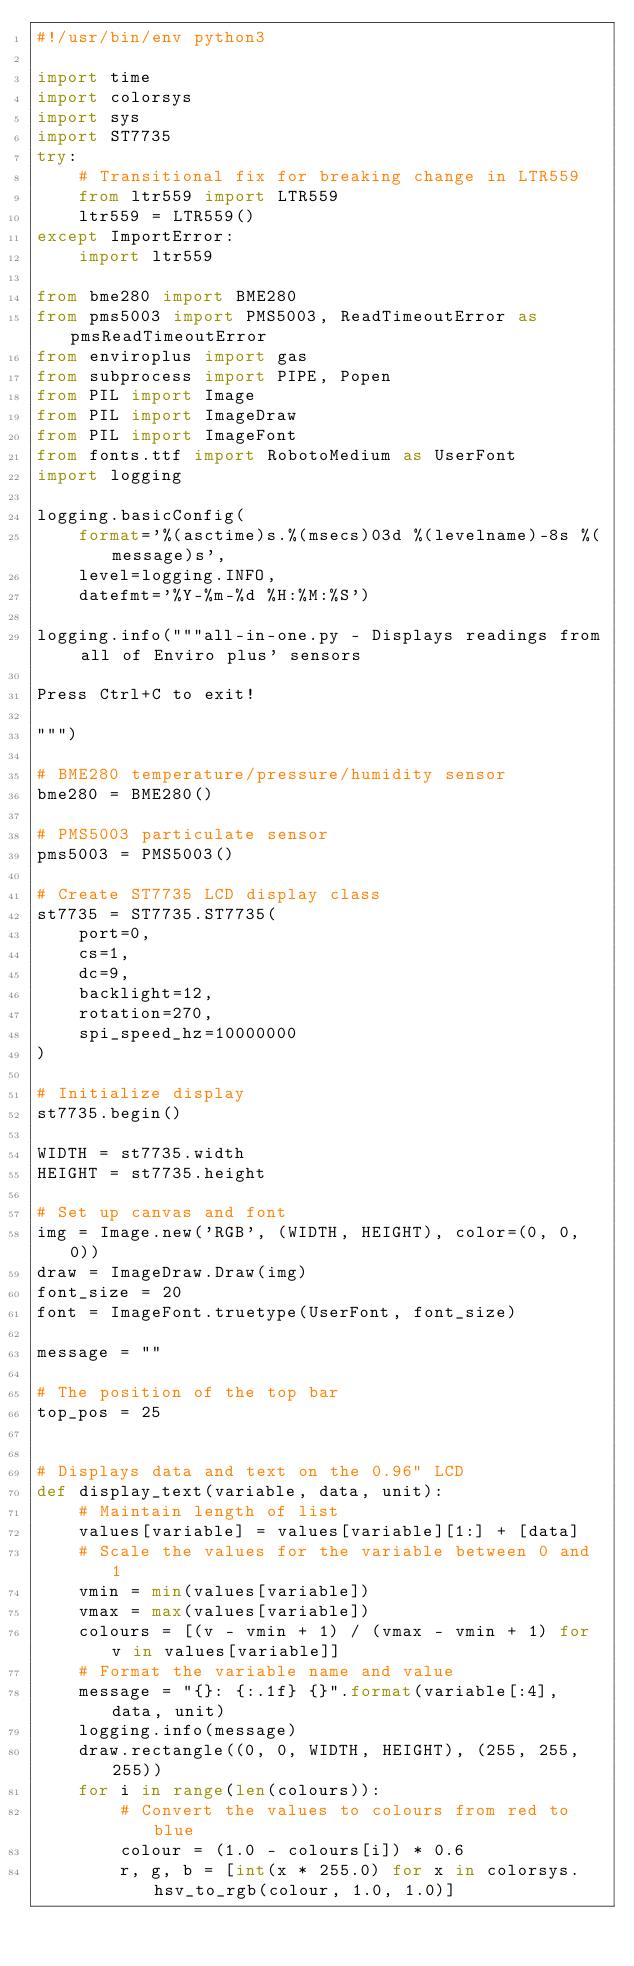<code> <loc_0><loc_0><loc_500><loc_500><_Python_>#!/usr/bin/env python3

import time
import colorsys
import sys
import ST7735
try:
    # Transitional fix for breaking change in LTR559
    from ltr559 import LTR559
    ltr559 = LTR559()
except ImportError:
    import ltr559

from bme280 import BME280
from pms5003 import PMS5003, ReadTimeoutError as pmsReadTimeoutError
from enviroplus import gas
from subprocess import PIPE, Popen
from PIL import Image
from PIL import ImageDraw
from PIL import ImageFont
from fonts.ttf import RobotoMedium as UserFont
import logging

logging.basicConfig(
    format='%(asctime)s.%(msecs)03d %(levelname)-8s %(message)s',
    level=logging.INFO,
    datefmt='%Y-%m-%d %H:%M:%S')

logging.info("""all-in-one.py - Displays readings from all of Enviro plus' sensors

Press Ctrl+C to exit!

""")

# BME280 temperature/pressure/humidity sensor
bme280 = BME280()

# PMS5003 particulate sensor
pms5003 = PMS5003()

# Create ST7735 LCD display class
st7735 = ST7735.ST7735(
    port=0,
    cs=1,
    dc=9,
    backlight=12,
    rotation=270,
    spi_speed_hz=10000000
)

# Initialize display
st7735.begin()

WIDTH = st7735.width
HEIGHT = st7735.height

# Set up canvas and font
img = Image.new('RGB', (WIDTH, HEIGHT), color=(0, 0, 0))
draw = ImageDraw.Draw(img)
font_size = 20
font = ImageFont.truetype(UserFont, font_size)

message = ""

# The position of the top bar
top_pos = 25


# Displays data and text on the 0.96" LCD
def display_text(variable, data, unit):
    # Maintain length of list
    values[variable] = values[variable][1:] + [data]
    # Scale the values for the variable between 0 and 1
    vmin = min(values[variable])
    vmax = max(values[variable])
    colours = [(v - vmin + 1) / (vmax - vmin + 1) for v in values[variable]]
    # Format the variable name and value
    message = "{}: {:.1f} {}".format(variable[:4], data, unit)
    logging.info(message)
    draw.rectangle((0, 0, WIDTH, HEIGHT), (255, 255, 255))
    for i in range(len(colours)):
        # Convert the values to colours from red to blue
        colour = (1.0 - colours[i]) * 0.6
        r, g, b = [int(x * 255.0) for x in colorsys.hsv_to_rgb(colour, 1.0, 1.0)]</code> 